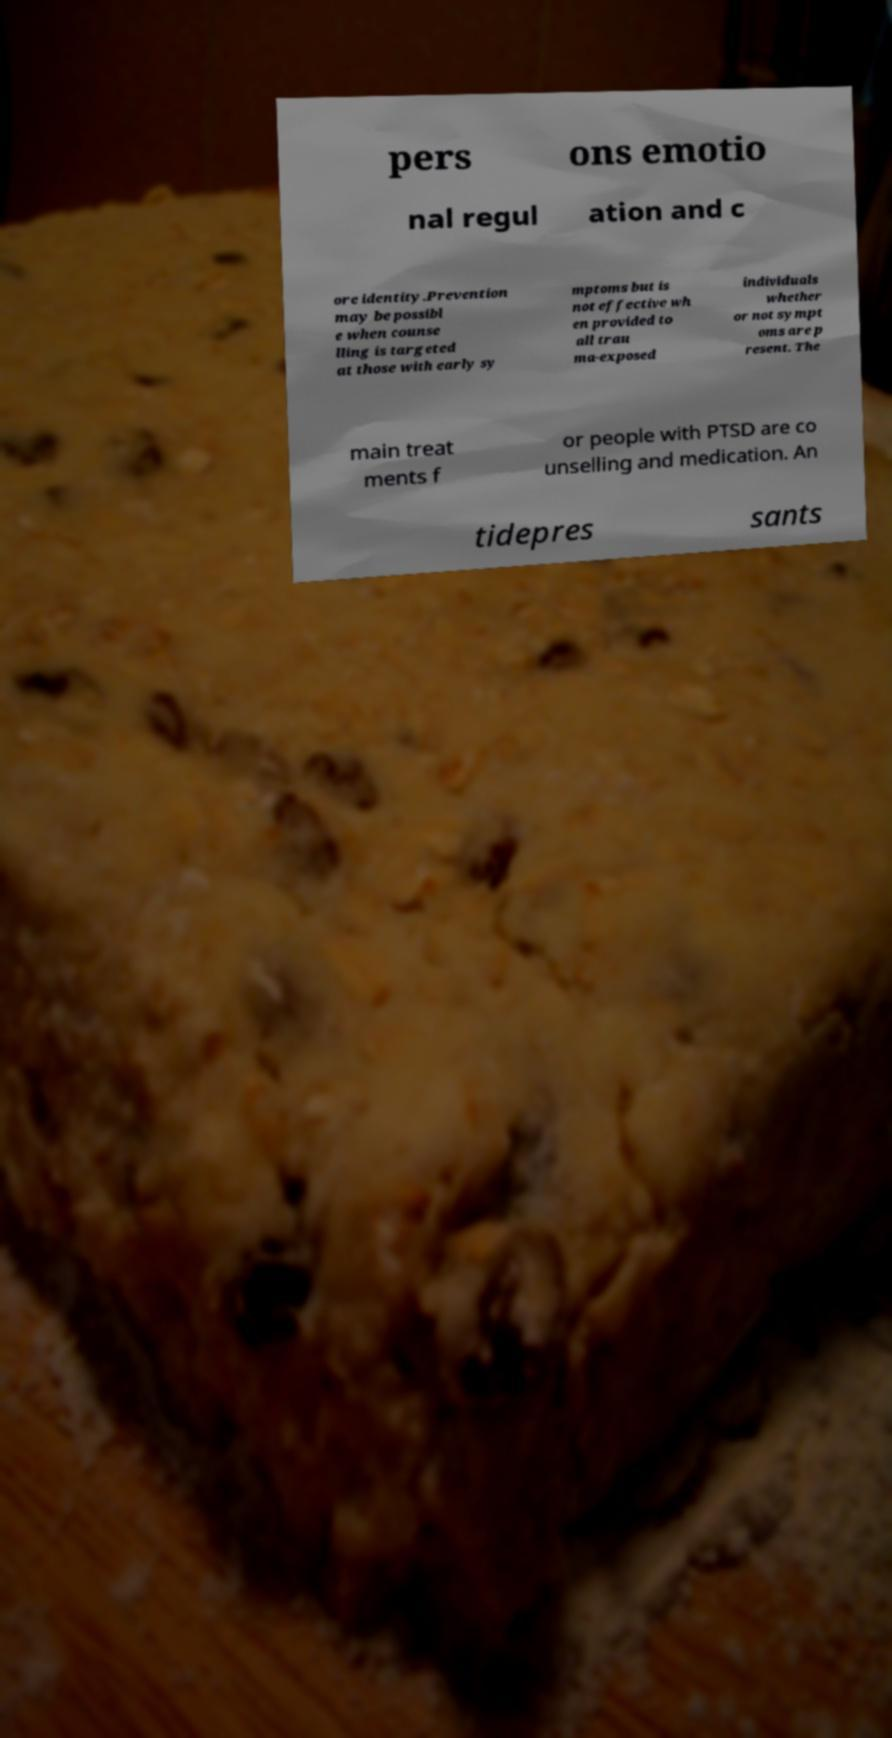For documentation purposes, I need the text within this image transcribed. Could you provide that? pers ons emotio nal regul ation and c ore identity.Prevention may be possibl e when counse lling is targeted at those with early sy mptoms but is not effective wh en provided to all trau ma-exposed individuals whether or not sympt oms are p resent. The main treat ments f or people with PTSD are co unselling and medication. An tidepres sants 